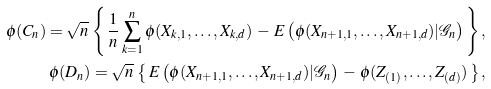Convert formula to latex. <formula><loc_0><loc_0><loc_500><loc_500>\phi ( { C _ { n } } ) = \sqrt { n } \, \left \{ \, \frac { 1 } { n } \sum _ { k = 1 } ^ { n } \phi ( X _ { k , 1 } , \dots , X _ { k , d } ) \, - \, E \left ( \phi ( X _ { n + 1 , 1 } , \dots , X _ { n + 1 , d } ) | \mathcal { G } _ { n } \right ) \, \right \} , \\ \phi ( { D _ { n } } ) = \sqrt { n } \, \left \{ \, E \left ( \phi ( X _ { n + 1 , 1 } , \dots , X _ { n + 1 , d } ) | \mathcal { G } _ { n } \right ) \, - \, \phi ( Z _ { ( 1 ) } , \dots , Z _ { ( d ) } ) \, \right \} ,</formula> 